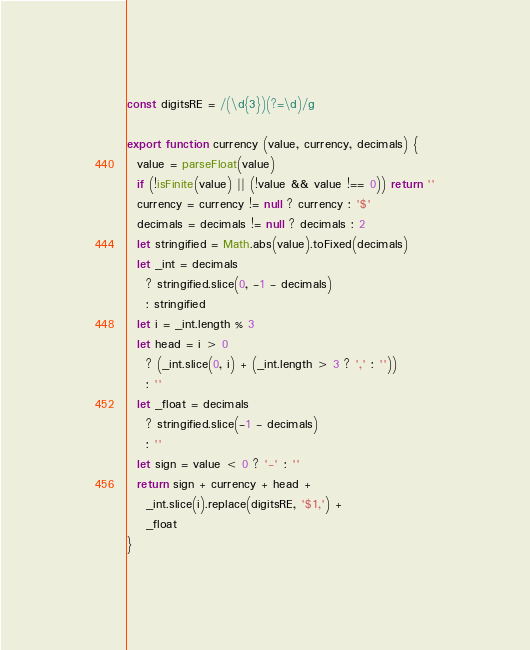<code> <loc_0><loc_0><loc_500><loc_500><_JavaScript_>const digitsRE = /(\d{3})(?=\d)/g

export function currency (value, currency, decimals) {
  value = parseFloat(value)
  if (!isFinite(value) || (!value && value !== 0)) return ''
  currency = currency != null ? currency : '$'
  decimals = decimals != null ? decimals : 2
  let stringified = Math.abs(value).toFixed(decimals)
  let _int = decimals
    ? stringified.slice(0, -1 - decimals)
    : stringified
  let i = _int.length % 3
  let head = i > 0
    ? (_int.slice(0, i) + (_int.length > 3 ? ',' : ''))
    : ''
  let _float = decimals
    ? stringified.slice(-1 - decimals)
    : ''
  let sign = value < 0 ? '-' : ''
  return sign + currency + head +
    _int.slice(i).replace(digitsRE, '$1,') +
    _float
}
</code> 